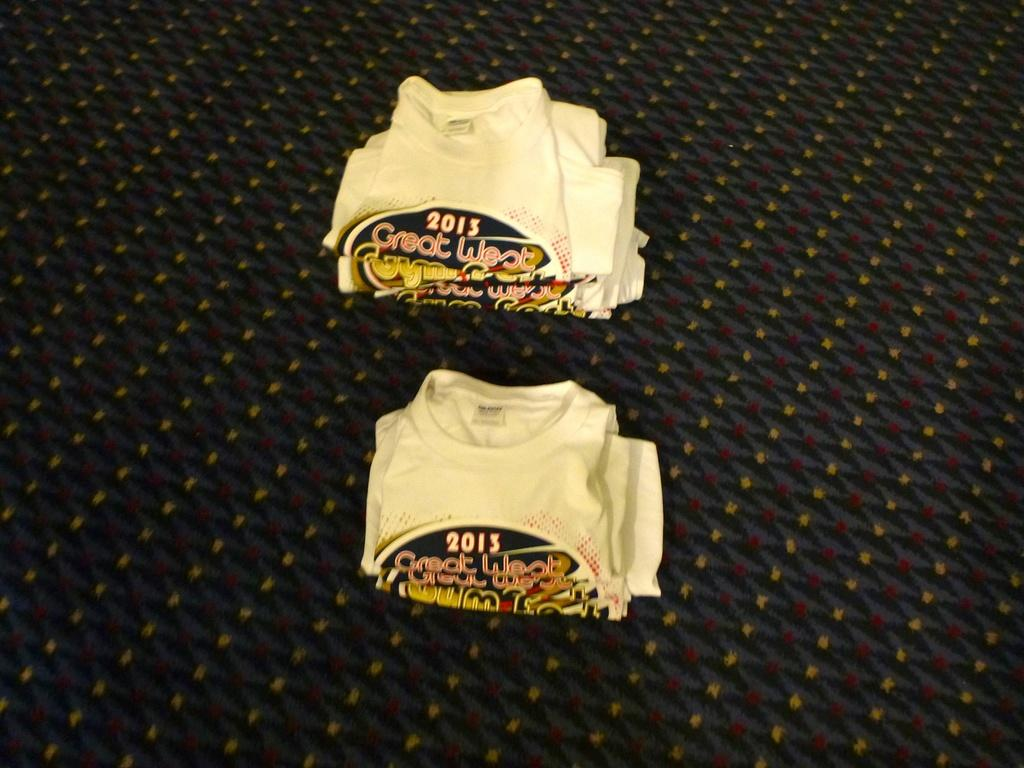<image>
Give a short and clear explanation of the subsequent image. Two piles of folded white t-shirts advertising a 2013 Great West event. 